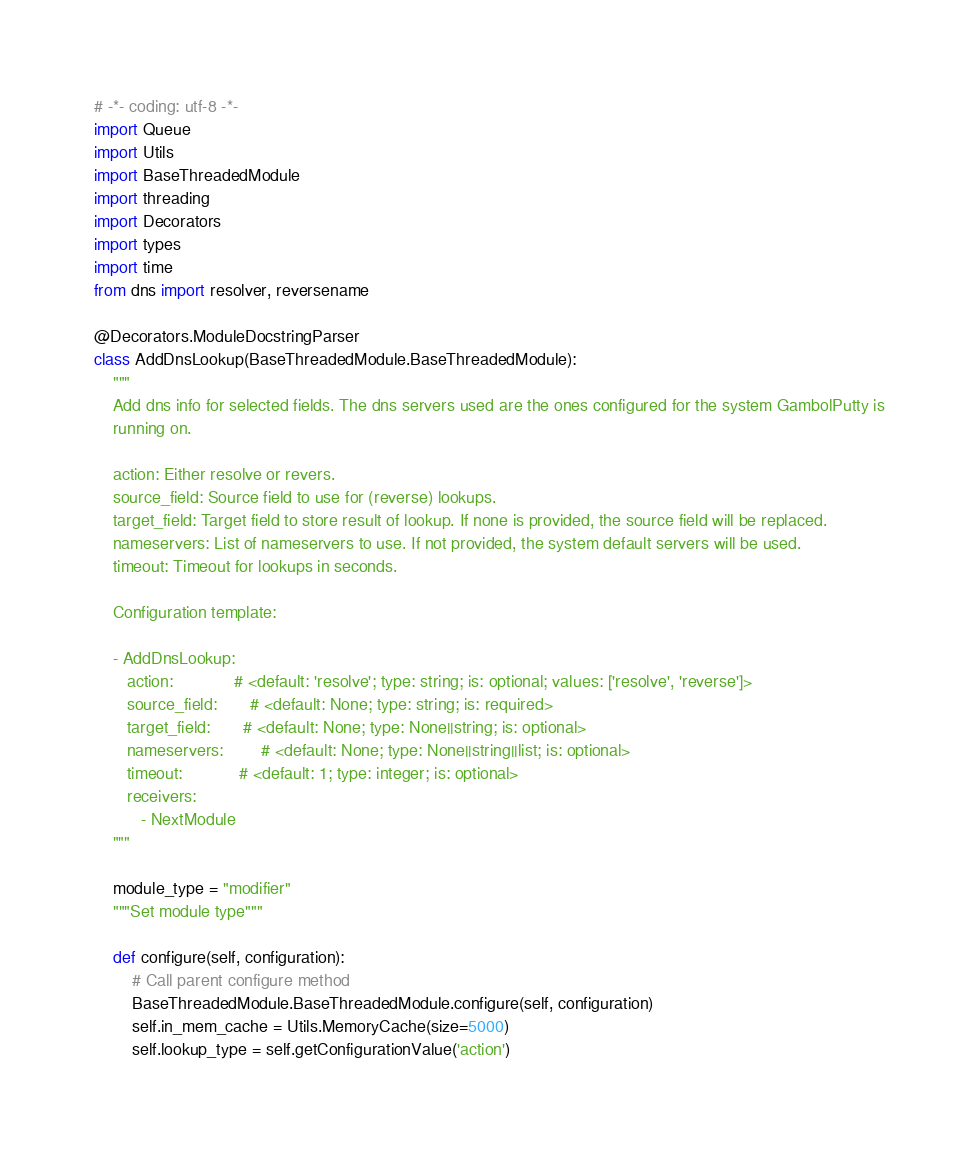Convert code to text. <code><loc_0><loc_0><loc_500><loc_500><_Python_># -*- coding: utf-8 -*-
import Queue
import Utils
import BaseThreadedModule
import threading
import Decorators
import types
import time
from dns import resolver, reversename

@Decorators.ModuleDocstringParser
class AddDnsLookup(BaseThreadedModule.BaseThreadedModule):
    """
    Add dns info for selected fields. The dns servers used are the ones configured for the system GambolPutty is
    running on.

    action: Either resolve or revers.
    source_field: Source field to use for (reverse) lookups.
    target_field: Target field to store result of lookup. If none is provided, the source field will be replaced.
    nameservers: List of nameservers to use. If not provided, the system default servers will be used.
    timeout: Timeout for lookups in seconds.

    Configuration template:

    - AddDnsLookup:
       action:             # <default: 'resolve'; type: string; is: optional; values: ['resolve', 'reverse']>
       source_field:       # <default: None; type: string; is: required>
       target_field:       # <default: None; type: None||string; is: optional>
       nameservers:        # <default: None; type: None||string||list; is: optional>
       timeout:            # <default: 1; type: integer; is: optional>
       receivers:
          - NextModule
    """

    module_type = "modifier"
    """Set module type"""

    def configure(self, configuration):
        # Call parent configure method
        BaseThreadedModule.BaseThreadedModule.configure(self, configuration)
        self.in_mem_cache = Utils.MemoryCache(size=5000)
        self.lookup_type = self.getConfigurationValue('action')</code> 